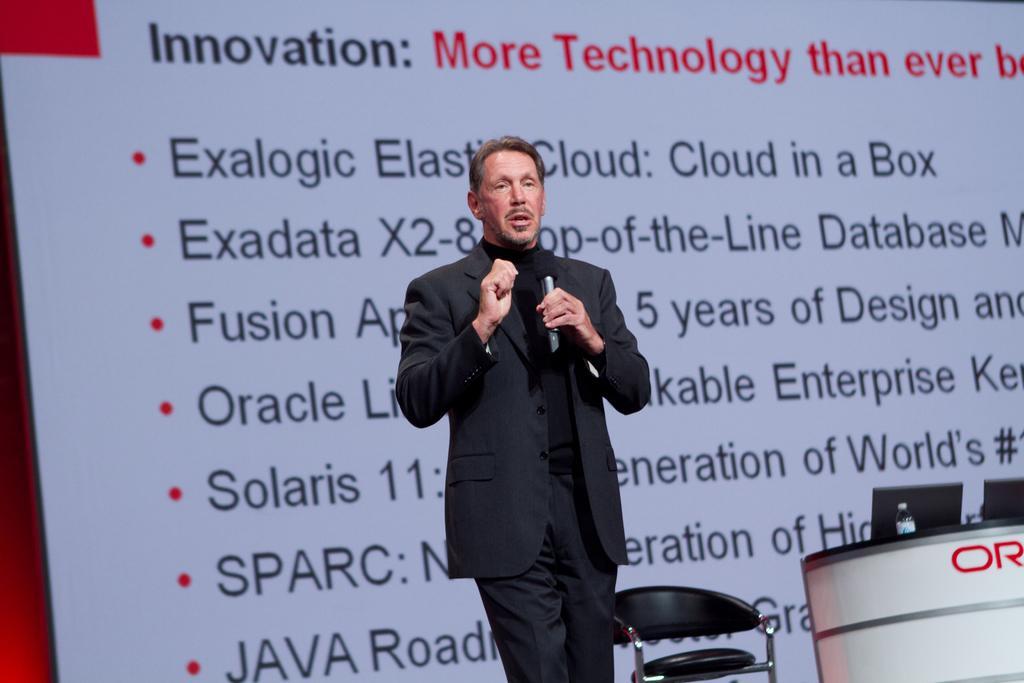Describe this image in one or two sentences. In this picture one man wearing black suit is talking. He is holding a mic. Beside him there is table and chair. On the table there are laptops and bottle. On the background there is a screen. 